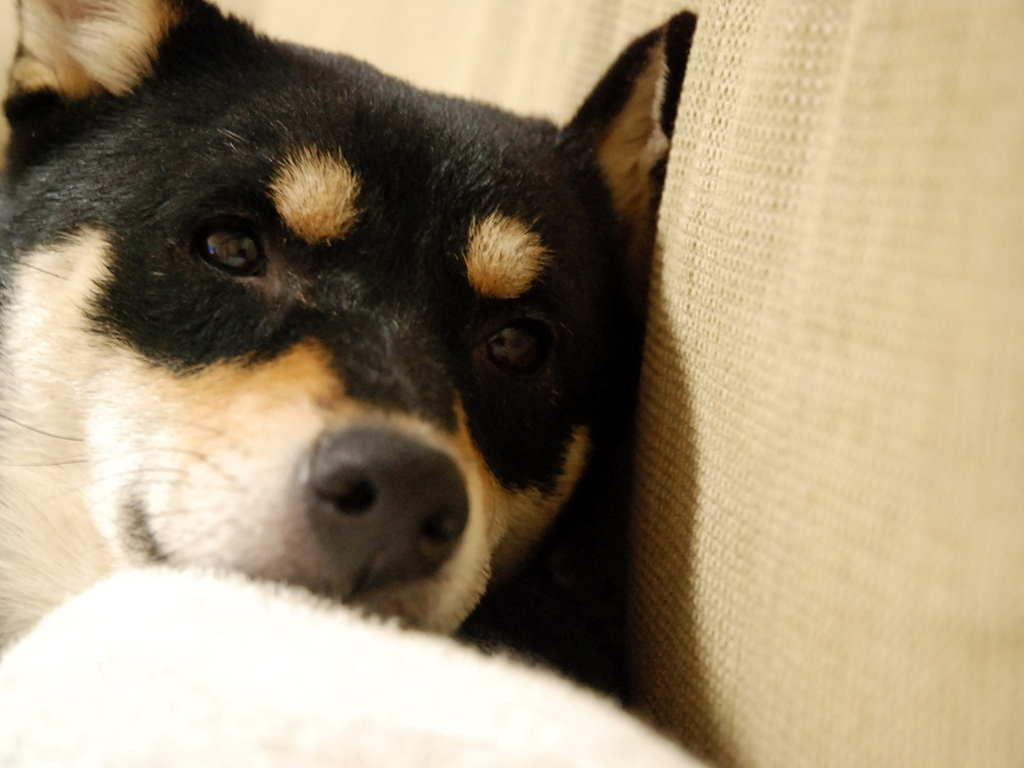This dog seems relaxed; could you infer any potential reasons for its demeanor based on the surroundings? The dog's relaxed state could be attributed to the comfortable domestic setting, possibly its home, where it feels safe and content. The soft furnishings and subdued lighting further contribute to an environment conducive to relaxation and tranquility. 